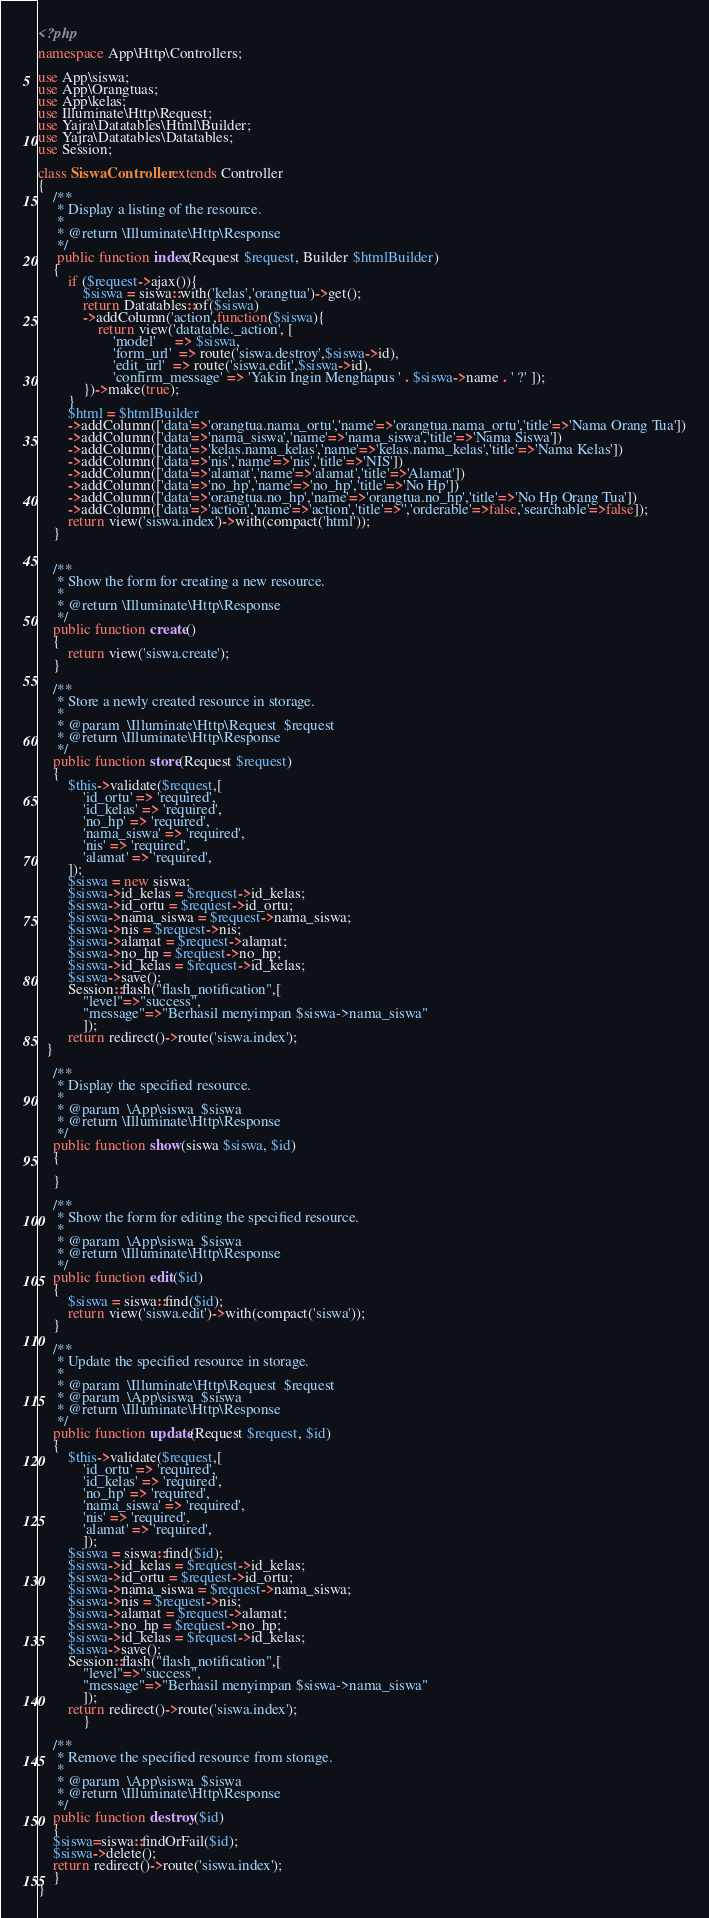<code> <loc_0><loc_0><loc_500><loc_500><_PHP_><?php

namespace App\Http\Controllers;

use App\siswa;
use App\Orangtuas;
use App\kelas;
use Illuminate\Http\Request;
use Yajra\Datatables\Html\Builder;
use Yajra\Datatables\Datatables;
use Session;

class SiswaController extends Controller
{
    /**
     * Display a listing of the resource.
     *
     * @return \Illuminate\Http\Response
     */
     public function index(Request $request, Builder $htmlBuilder)
    {
        if ($request->ajax()){
            $siswa = siswa::with('kelas','orangtua')->get();
            return Datatables::of($siswa)
            ->addColumn('action',function($siswa){
                return view('datatable._action', [
                    'model'     => $siswa,
                    'form_url'  => route('siswa.destroy',$siswa->id),
                    'edit_url'  => route('siswa.edit',$siswa->id),
                    'confirm_message' => 'Yakin Ingin Menghapus ' . $siswa->name . ' ?' ]);
            })->make(true);
        }
        $html = $htmlBuilder
        ->addColumn(['data'=>'orangtua.nama_ortu','name'=>'orangtua.nama_ortu','title'=>'Nama Orang Tua'])
        ->addColumn(['data'=>'nama_siswa','name'=>'nama_siswa','title'=>'Nama Siswa'])
        ->addColumn(['data'=>'kelas.nama_kelas','name'=>'kelas.nama_kelas','title'=>'Nama Kelas'])
        ->addColumn(['data'=>'nis','name'=>'nis','title'=>'NIS'])
        ->addColumn(['data'=>'alamat','name'=>'alamat','title'=>'Alamat'])
        ->addColumn(['data'=>'no_hp','name'=>'no_hp','title'=>'No Hp'])
        ->addColumn(['data'=>'orangtua.no_hp','name'=>'orangtua.no_hp','title'=>'No Hp Orang Tua'])
        ->addColumn(['data'=>'action','name'=>'action','title'=>'','orderable'=>false,'searchable'=>false]);
        return view('siswa.index')->with(compact('html'));
    }


    /**
     * Show the form for creating a new resource.
     *
     * @return \Illuminate\Http\Response
     */
    public function create()
    {
        return view('siswa.create');
    }

    /**
     * Store a newly created resource in storage.
     *
     * @param  \Illuminate\Http\Request  $request
     * @return \Illuminate\Http\Response
     */
    public function store(Request $request)
    {
        $this->validate($request,[
            'id_ortu' => 'required',
            'id_kelas' => 'required',
            'no_hp' => 'required',
            'nama_siswa' => 'required',
            'nis' => 'required',
            'alamat' => 'required',
        ]);
        $siswa = new siswa;
        $siswa->id_kelas = $request->id_kelas;
        $siswa->id_ortu = $request->id_ortu;
        $siswa->nama_siswa = $request->nama_siswa;
        $siswa->nis = $request->nis;
        $siswa->alamat = $request->alamat;
        $siswa->no_hp = $request->no_hp;
        $siswa->id_kelas = $request->id_kelas;
        $siswa->save();
        Session::flash("flash_notification",[
            "level"=>"success",
            "message"=>"Berhasil menyimpan $siswa->nama_siswa"
            ]);
        return redirect()->route('siswa.index');  
  }

    /**
     * Display the specified resource.
     *
     * @param  \App\siswa  $siswa
     * @return \Illuminate\Http\Response
     */
    public function show(siswa $siswa, $id)
    {
        
    }

    /**
     * Show the form for editing the specified resource.
     *
     * @param  \App\siswa  $siswa
     * @return \Illuminate\Http\Response
     */
    public function edit($id)
    {
        $siswa = siswa::find($id);
        return view('siswa.edit')->with(compact('siswa'));
    }

    /**
     * Update the specified resource in storage.
     *
     * @param  \Illuminate\Http\Request  $request
     * @param  \App\siswa  $siswa
     * @return \Illuminate\Http\Response
     */
    public function update(Request $request, $id)
    {
        $this->validate($request,[
            'id_ortu' => 'required',
            'id_kelas' => 'required',
            'no_hp' => 'required',
            'nama_siswa' => 'required',
            'nis' => 'required',
            'alamat' => 'required',
            ]);
        $siswa = siswa::find($id);
        $siswa->id_kelas = $request->id_kelas;
        $siswa->id_ortu = $request->id_ortu;
        $siswa->nama_siswa = $request->nama_siswa;
        $siswa->nis = $request->nis;
        $siswa->alamat = $request->alamat;
        $siswa->no_hp = $request->no_hp;
        $siswa->id_kelas = $request->id_kelas;
        $siswa->save();
        Session::flash("flash_notification",[
            "level"=>"success",
            "message"=>"Berhasil menyimpan $siswa->nama_siswa"
            ]);
        return redirect()->route('siswa.index');
            }

    /**
     * Remove the specified resource from storage.
     *
     * @param  \App\siswa  $siswa
     * @return \Illuminate\Http\Response
     */
    public function destroy($id)
    {
    $siswa=siswa::findOrFail($id);
    $siswa->delete();
    return redirect()->route('siswa.index');    
    }
}
</code> 